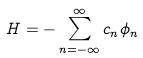Convert formula to latex. <formula><loc_0><loc_0><loc_500><loc_500>H = - \sum _ { n = - \infty } ^ { \infty } c _ { n } \phi _ { n }</formula> 